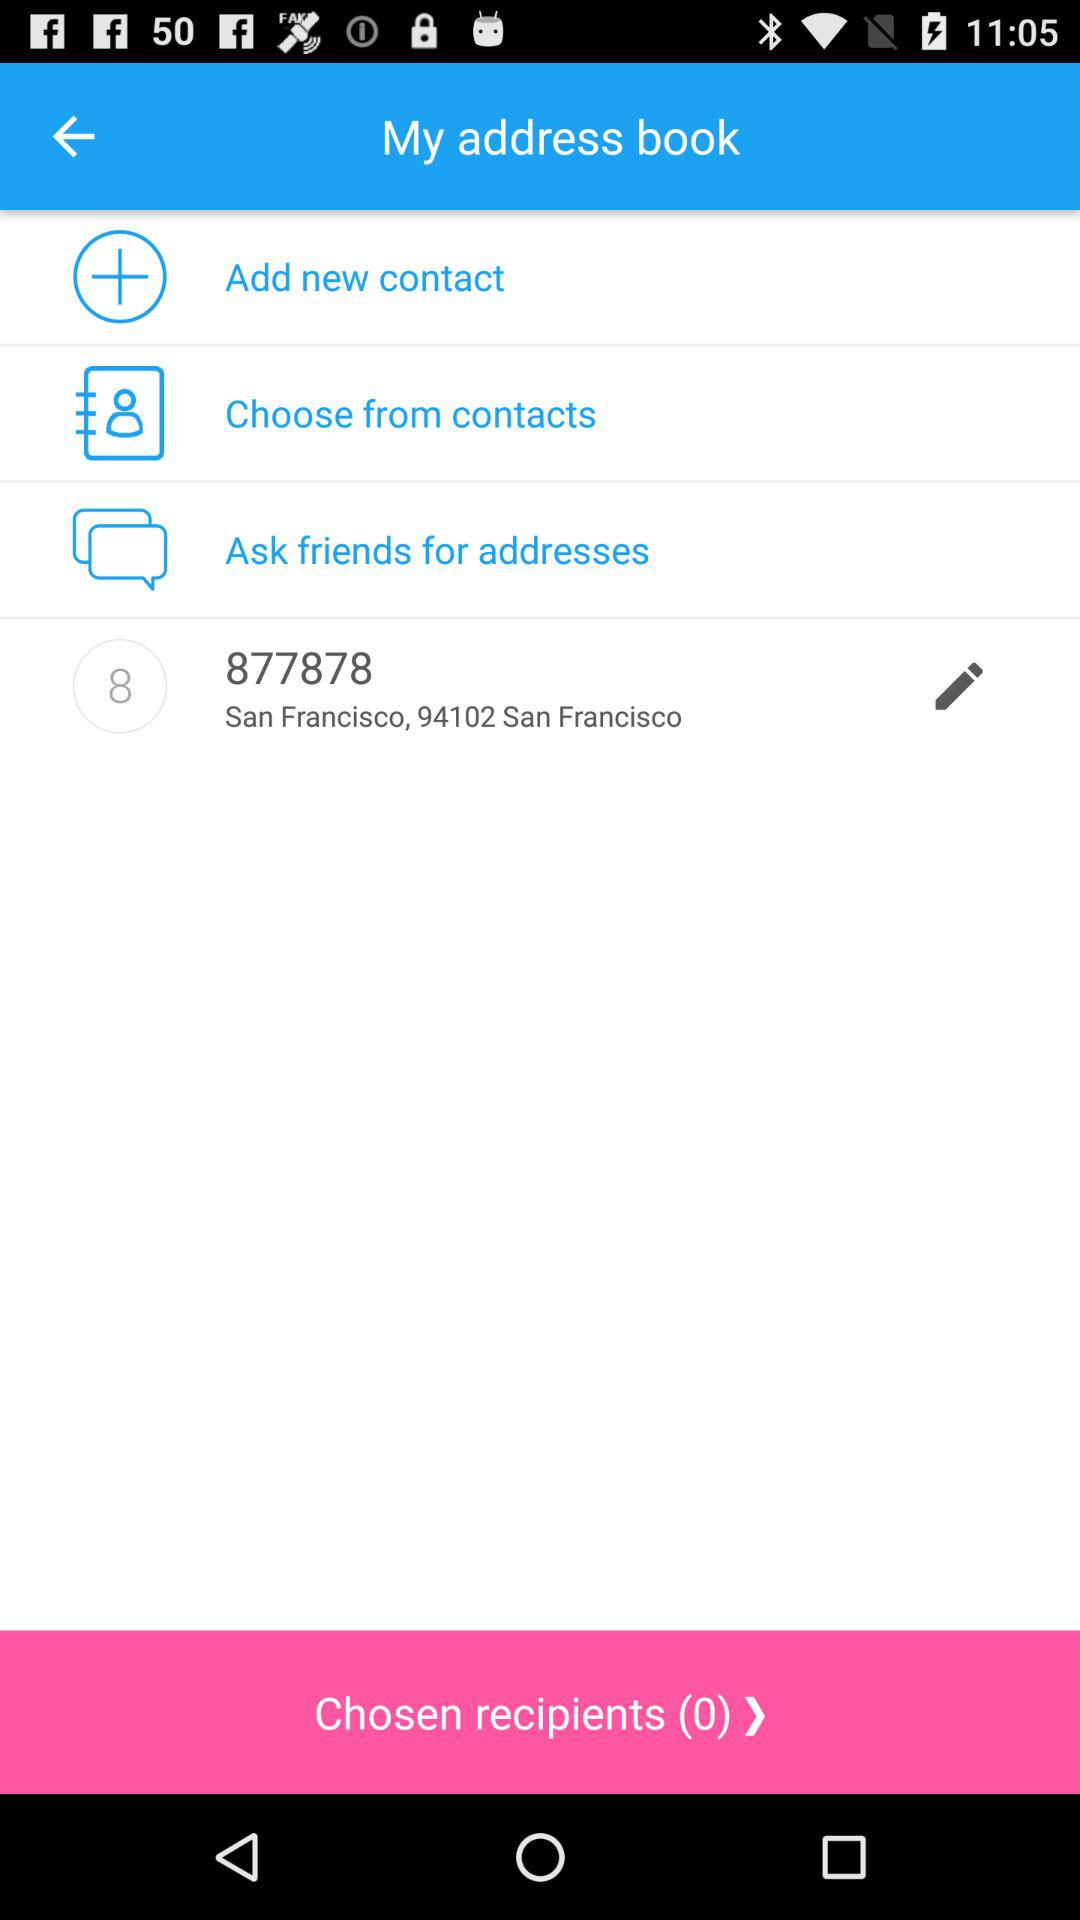How many contacts are in the address book?
When the provided information is insufficient, respond with <no answer>. <no answer> 